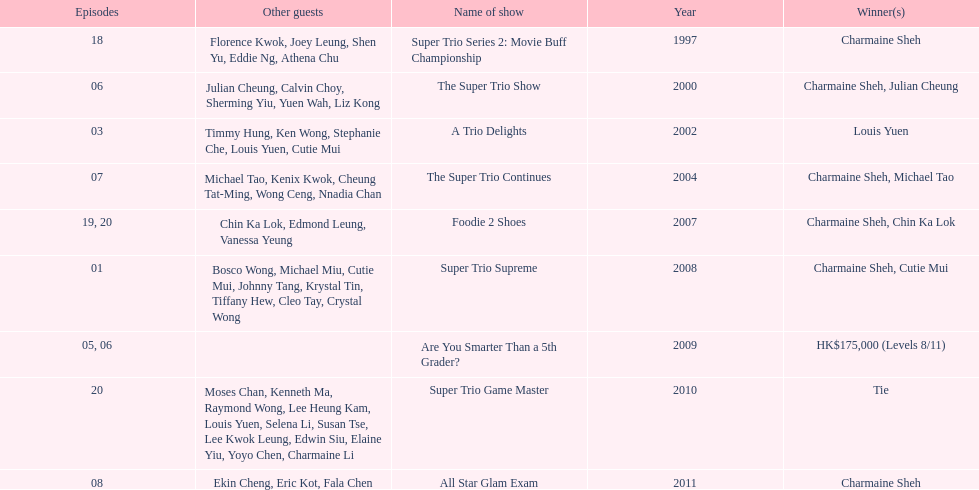What was the total number of trio series shows were charmaine sheh on? 6. 